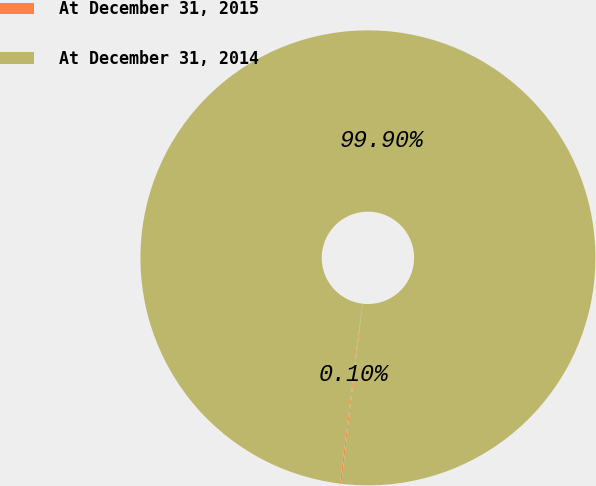<chart> <loc_0><loc_0><loc_500><loc_500><pie_chart><fcel>At December 31, 2015<fcel>At December 31, 2014<nl><fcel>0.1%<fcel>99.9%<nl></chart> 